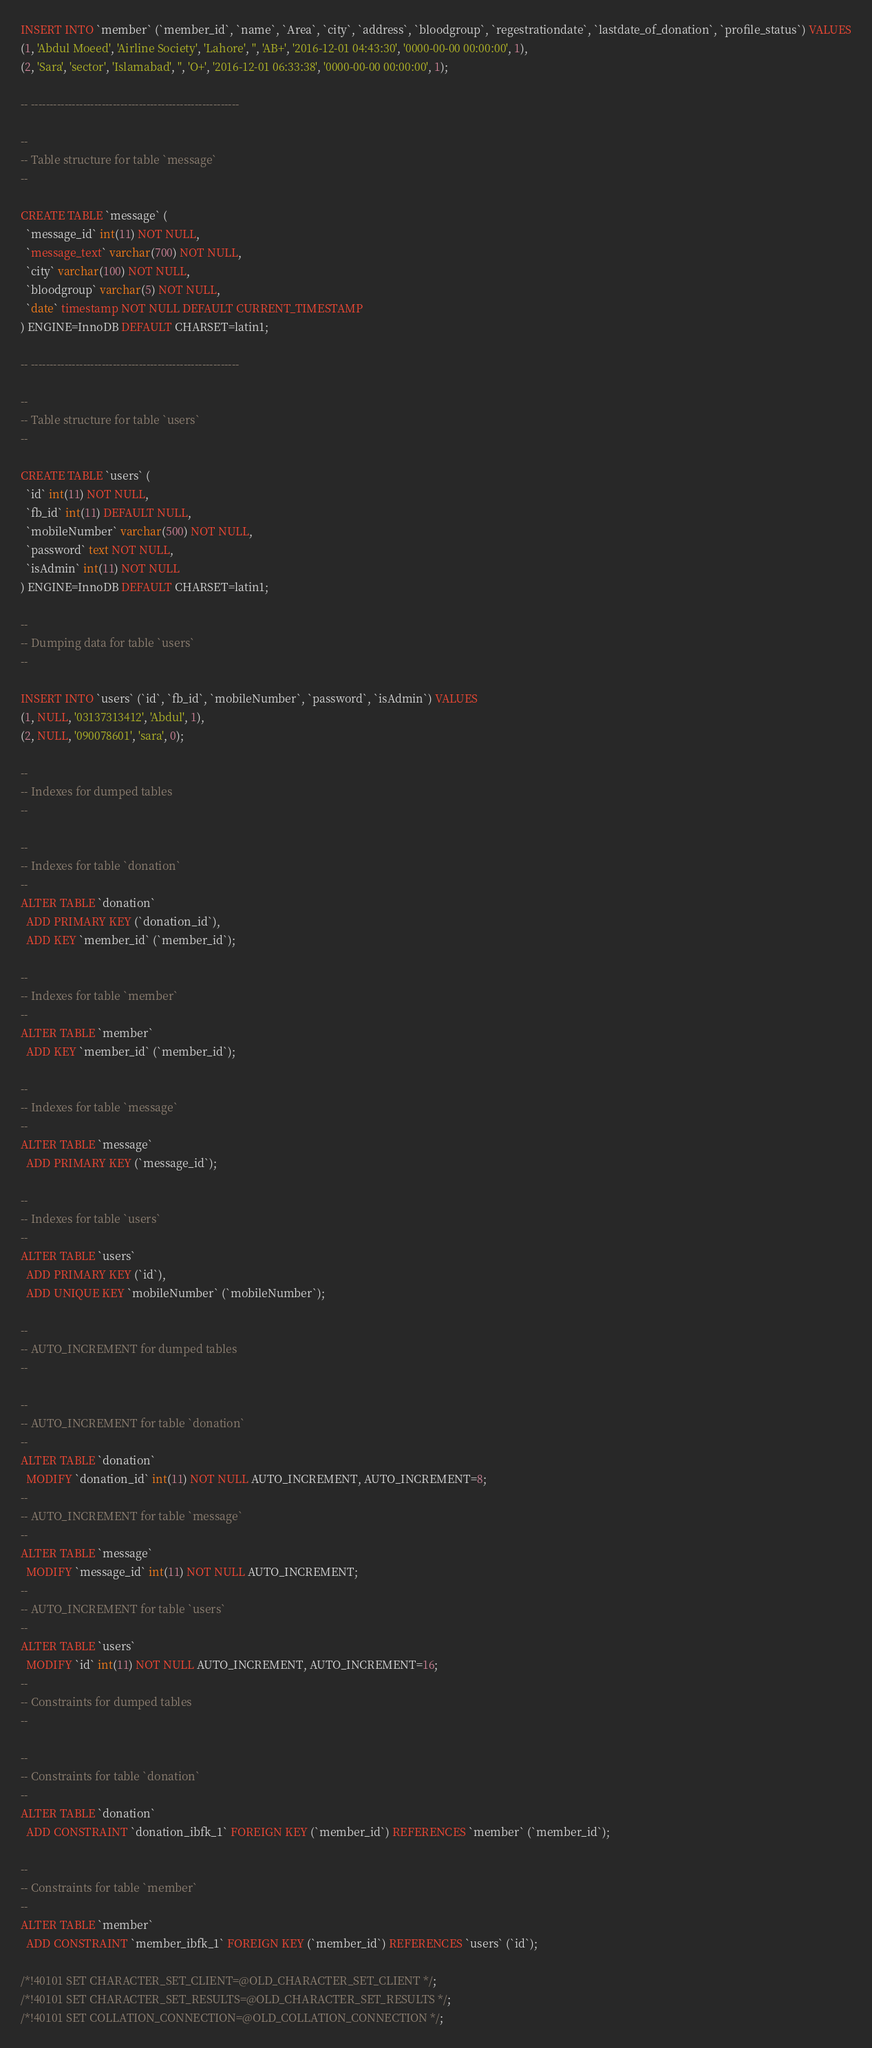Convert code to text. <code><loc_0><loc_0><loc_500><loc_500><_SQL_>INSERT INTO `member` (`member_id`, `name`, `Area`, `city`, `address`, `bloodgroup`, `regestrationdate`, `lastdate_of_donation`, `profile_status`) VALUES
(1, 'Abdul Moeed', 'Airline Society', 'Lahore', '', 'AB+', '2016-12-01 04:43:30', '0000-00-00 00:00:00', 1),
(2, 'Sara', 'sector', 'Islamabad', '', 'O+', '2016-12-01 06:33:38', '0000-00-00 00:00:00', 1);

-- --------------------------------------------------------

--
-- Table structure for table `message`
--

CREATE TABLE `message` (
  `message_id` int(11) NOT NULL,
  `message_text` varchar(700) NOT NULL,
  `city` varchar(100) NOT NULL,
  `bloodgroup` varchar(5) NOT NULL,
  `date` timestamp NOT NULL DEFAULT CURRENT_TIMESTAMP
) ENGINE=InnoDB DEFAULT CHARSET=latin1;

-- --------------------------------------------------------

--
-- Table structure for table `users`
--

CREATE TABLE `users` (
  `id` int(11) NOT NULL,
  `fb_id` int(11) DEFAULT NULL,
  `mobileNumber` varchar(500) NOT NULL,
  `password` text NOT NULL,
  `isAdmin` int(11) NOT NULL
) ENGINE=InnoDB DEFAULT CHARSET=latin1;

--
-- Dumping data for table `users`
--

INSERT INTO `users` (`id`, `fb_id`, `mobileNumber`, `password`, `isAdmin`) VALUES
(1, NULL, '03137313412', 'Abdul', 1),
(2, NULL, '090078601', 'sara', 0);

--
-- Indexes for dumped tables
--

--
-- Indexes for table `donation`
--
ALTER TABLE `donation`
  ADD PRIMARY KEY (`donation_id`),
  ADD KEY `member_id` (`member_id`);

--
-- Indexes for table `member`
--
ALTER TABLE `member`
  ADD KEY `member_id` (`member_id`);

--
-- Indexes for table `message`
--
ALTER TABLE `message`
  ADD PRIMARY KEY (`message_id`);

--
-- Indexes for table `users`
--
ALTER TABLE `users`
  ADD PRIMARY KEY (`id`),
  ADD UNIQUE KEY `mobileNumber` (`mobileNumber`);

--
-- AUTO_INCREMENT for dumped tables
--

--
-- AUTO_INCREMENT for table `donation`
--
ALTER TABLE `donation`
  MODIFY `donation_id` int(11) NOT NULL AUTO_INCREMENT, AUTO_INCREMENT=8;
--
-- AUTO_INCREMENT for table `message`
--
ALTER TABLE `message`
  MODIFY `message_id` int(11) NOT NULL AUTO_INCREMENT;
--
-- AUTO_INCREMENT for table `users`
--
ALTER TABLE `users`
  MODIFY `id` int(11) NOT NULL AUTO_INCREMENT, AUTO_INCREMENT=16;
--
-- Constraints for dumped tables
--

--
-- Constraints for table `donation`
--
ALTER TABLE `donation`
  ADD CONSTRAINT `donation_ibfk_1` FOREIGN KEY (`member_id`) REFERENCES `member` (`member_id`);

--
-- Constraints for table `member`
--
ALTER TABLE `member`
  ADD CONSTRAINT `member_ibfk_1` FOREIGN KEY (`member_id`) REFERENCES `users` (`id`);

/*!40101 SET CHARACTER_SET_CLIENT=@OLD_CHARACTER_SET_CLIENT */;
/*!40101 SET CHARACTER_SET_RESULTS=@OLD_CHARACTER_SET_RESULTS */;
/*!40101 SET COLLATION_CONNECTION=@OLD_COLLATION_CONNECTION */;
</code> 